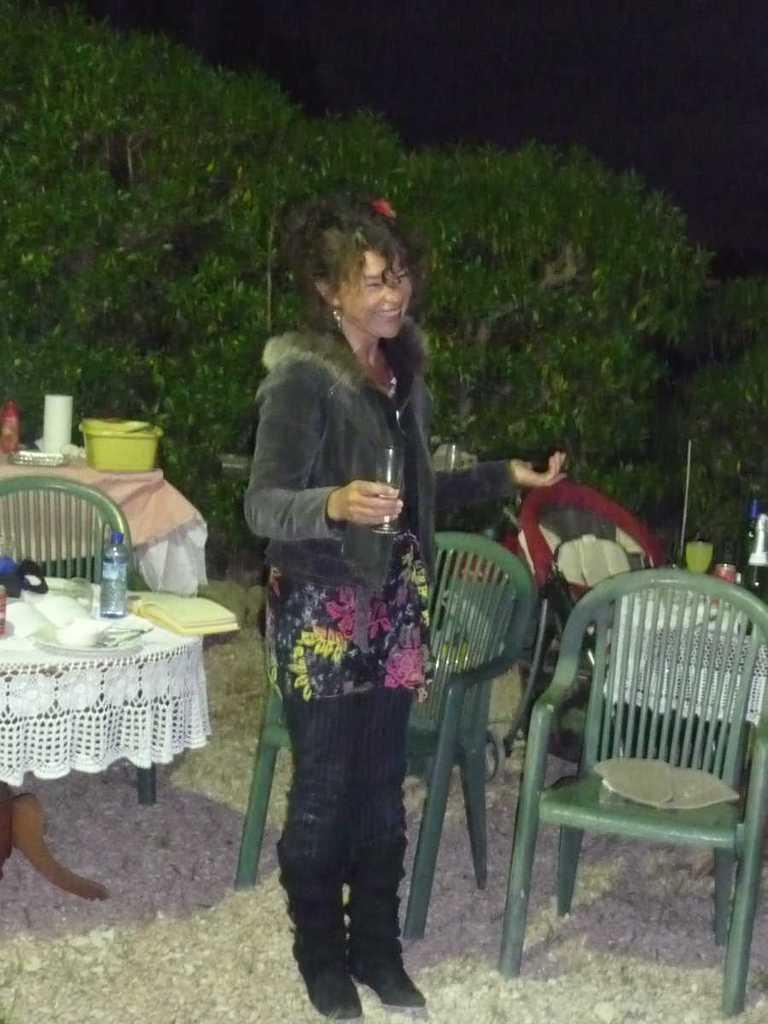Please provide a concise description of this image. There is a woman standing with a glass in her hand. There is a chair. There is a table. The bottle is placed on the table. There are dishes on the table. In the background there are trees. 